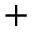<formula> <loc_0><loc_0><loc_500><loc_500>+</formula> 